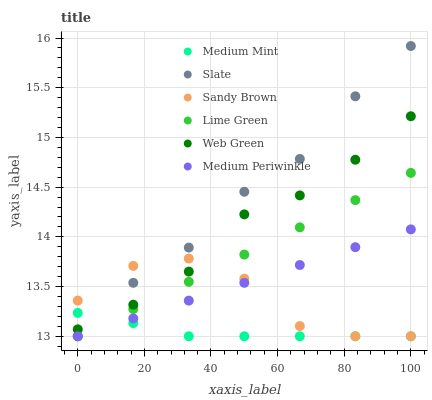Does Medium Mint have the minimum area under the curve?
Answer yes or no. Yes. Does Slate have the maximum area under the curve?
Answer yes or no. Yes. Does Sandy Brown have the minimum area under the curve?
Answer yes or no. No. Does Sandy Brown have the maximum area under the curve?
Answer yes or no. No. Is Medium Periwinkle the smoothest?
Answer yes or no. Yes. Is Sandy Brown the roughest?
Answer yes or no. Yes. Is Slate the smoothest?
Answer yes or no. No. Is Slate the roughest?
Answer yes or no. No. Does Medium Mint have the lowest value?
Answer yes or no. Yes. Does Web Green have the lowest value?
Answer yes or no. No. Does Slate have the highest value?
Answer yes or no. Yes. Does Sandy Brown have the highest value?
Answer yes or no. No. Is Medium Periwinkle less than Web Green?
Answer yes or no. Yes. Is Web Green greater than Medium Periwinkle?
Answer yes or no. Yes. Does Sandy Brown intersect Web Green?
Answer yes or no. Yes. Is Sandy Brown less than Web Green?
Answer yes or no. No. Is Sandy Brown greater than Web Green?
Answer yes or no. No. Does Medium Periwinkle intersect Web Green?
Answer yes or no. No. 